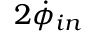<formula> <loc_0><loc_0><loc_500><loc_500>2 \dot { \phi } _ { i n }</formula> 